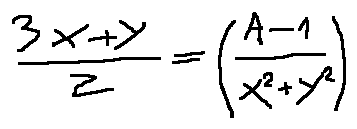Convert formula to latex. <formula><loc_0><loc_0><loc_500><loc_500>\frac { 3 x + y } { z } = ( \frac { A - 1 } { x ^ { 2 } + y ^ { 2 } } )</formula> 